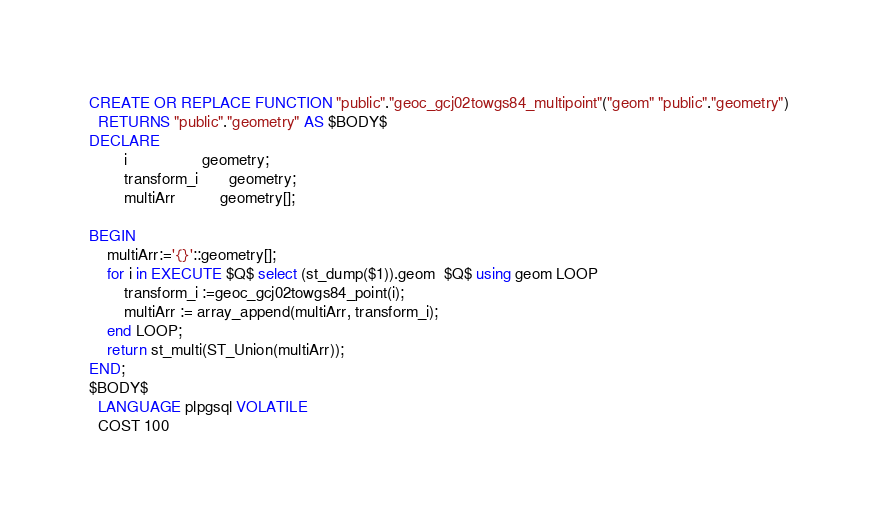Convert code to text. <code><loc_0><loc_0><loc_500><loc_500><_SQL_>CREATE OR REPLACE FUNCTION "public"."geoc_gcj02towgs84_multipoint"("geom" "public"."geometry")
  RETURNS "public"."geometry" AS $BODY$
DECLARE
		i                 geometry;
		transform_i       geometry;
		multiArr          geometry[]; 
	
BEGIN
    multiArr:='{}'::geometry[];
	for i in EXECUTE $Q$ select (st_dump($1)).geom  $Q$ using geom LOOP
	  	transform_i :=geoc_gcj02towgs84_point(i);
		multiArr := array_append(multiArr, transform_i);
	end LOOP;
	return st_multi(ST_Union(multiArr));
END;
$BODY$
  LANGUAGE plpgsql VOLATILE
  COST 100</code> 